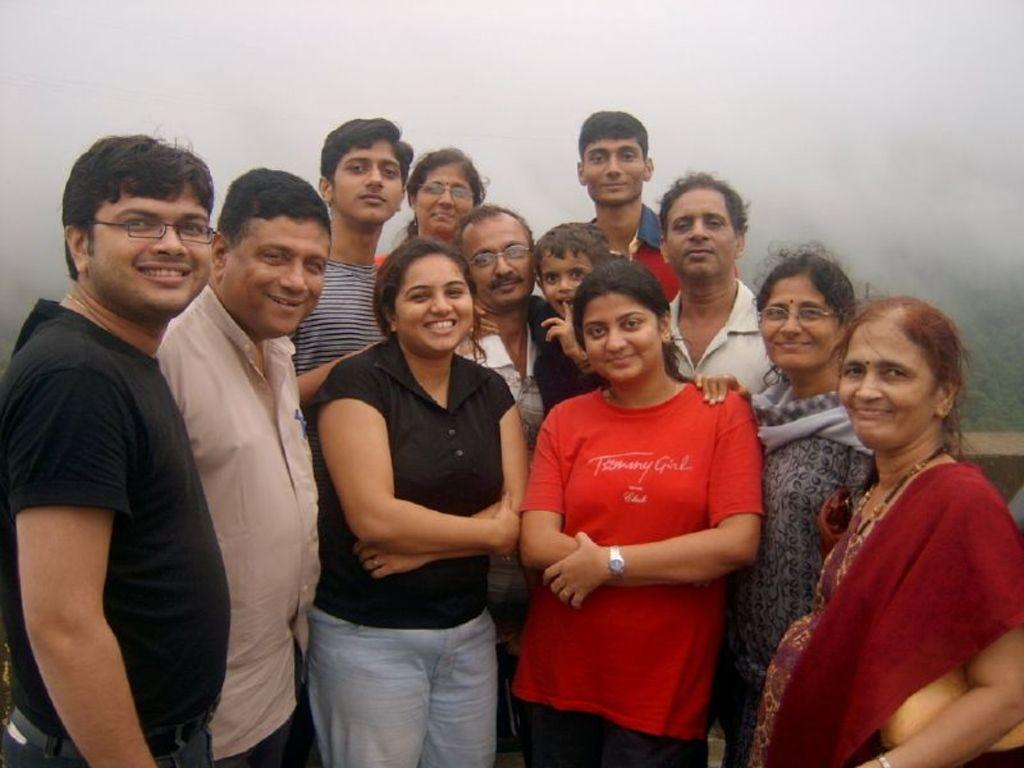How many people can be seen in the image? There are a few people in the image. What is visible in the background of the image? There is fog in the background of the image. What type of vegetation is present in the image? There are plants visible in the image. What can be found on the right side of the image? There is an object on the right side of the image. What invention is being demonstrated by the people in the image? There is no invention being demonstrated in the image; it simply shows people in a setting with fog and plants. 